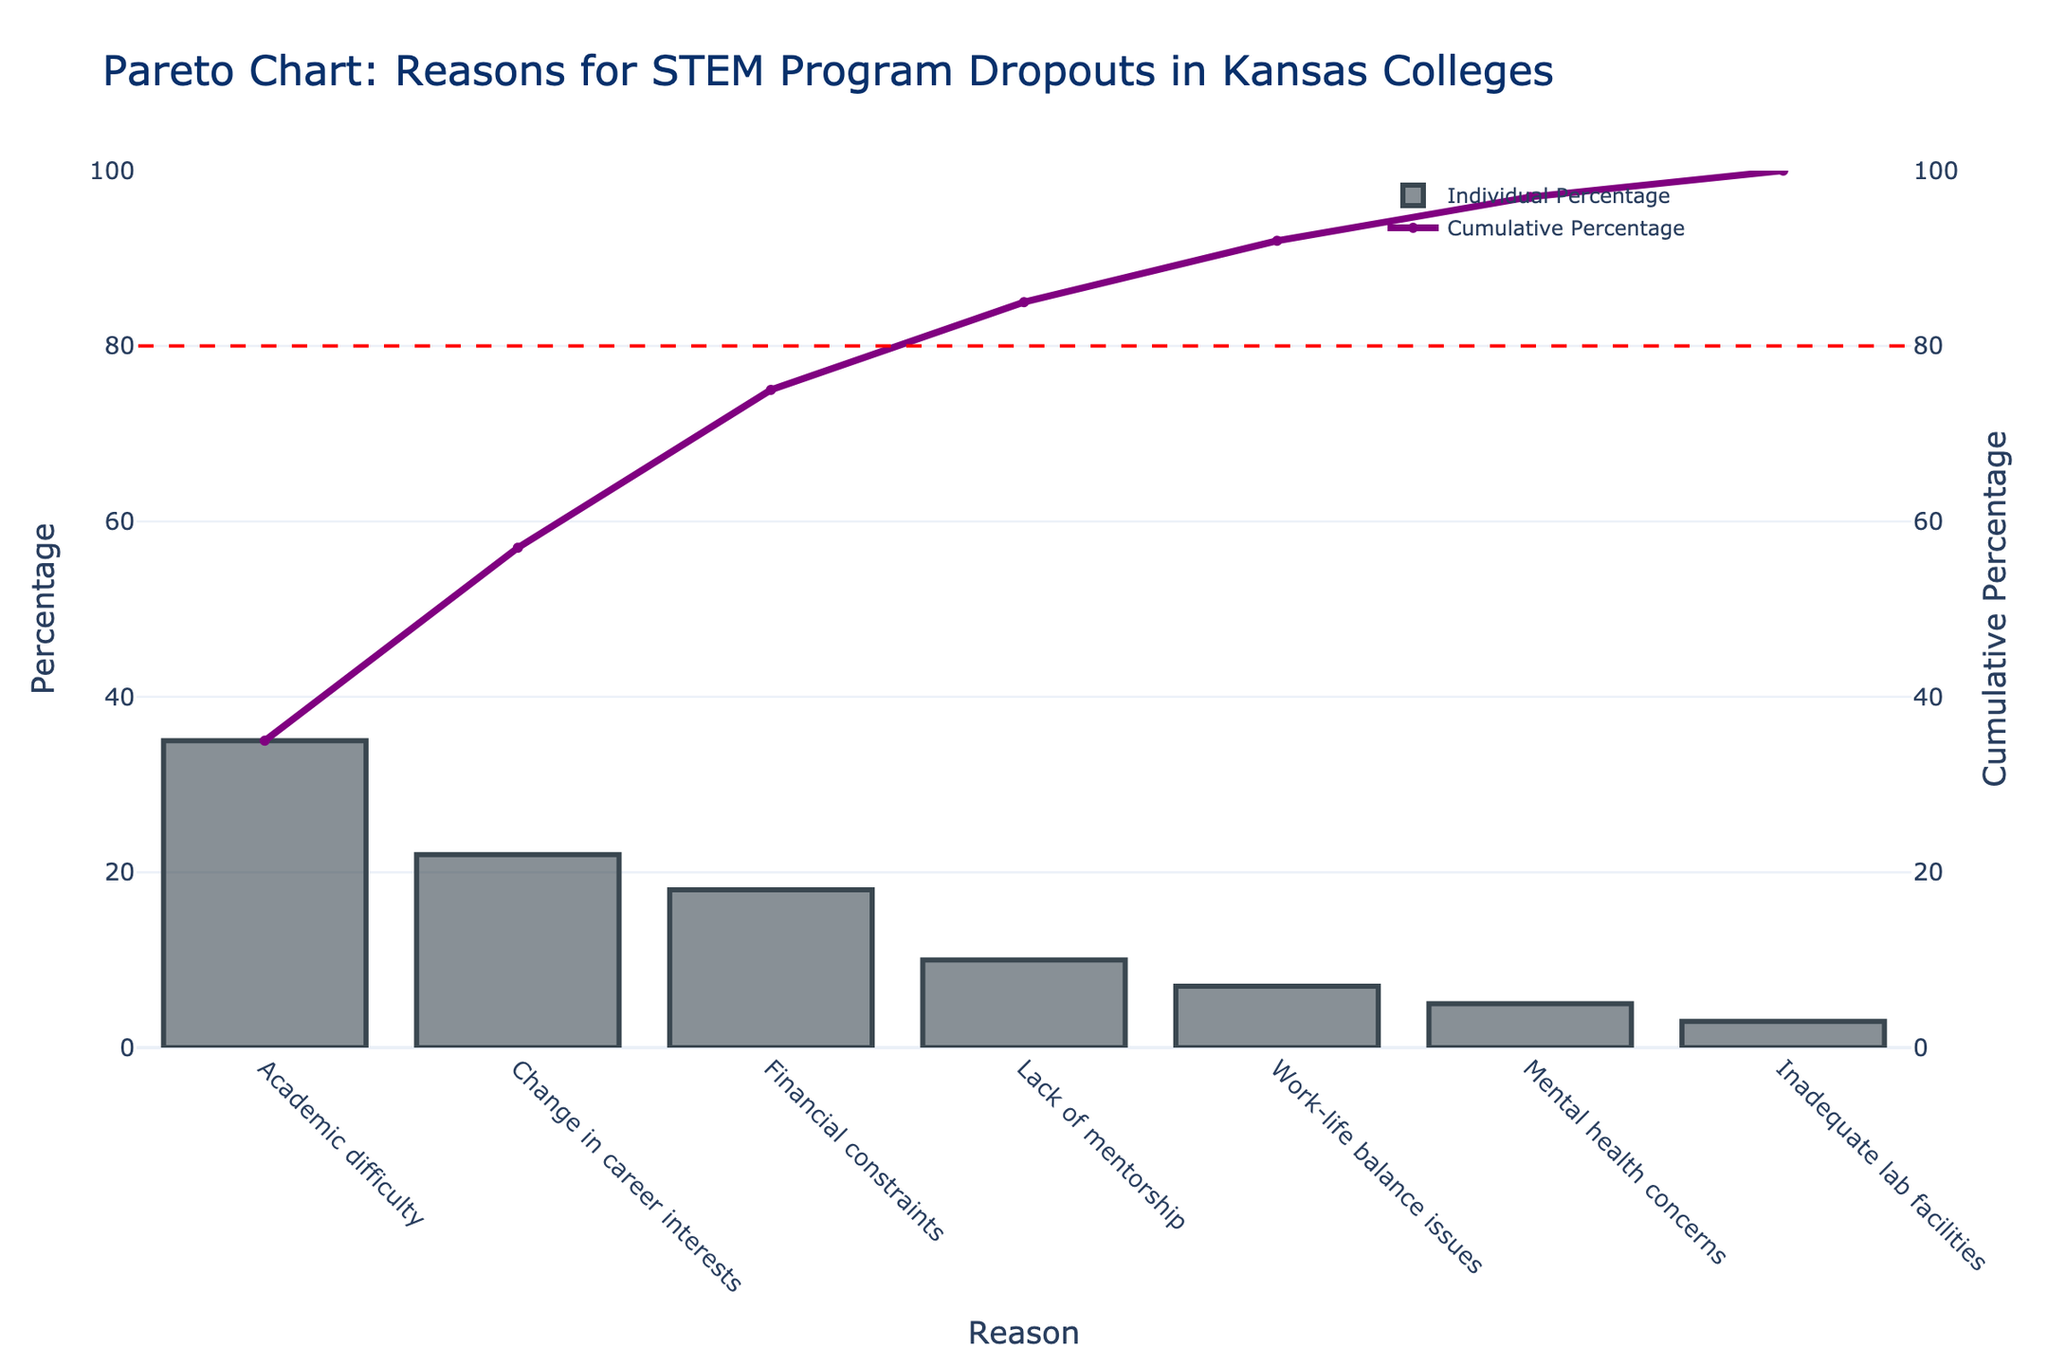What is the title of the chart? The title of the chart is located at the top and provides a summary of the chart's content. In this case, the title is found at the top center of the chart.
Answer: Pareto Chart: Reasons for STEM Program Dropouts in Kansas Colleges What reason accounts for the highest percentage of STEM program dropouts? The highest percentage bar represents the most frequent reason for dropouts and is positioned as the leftmost bar.
Answer: Academic difficulty What are the percentages for 'Work-life balance issues' and 'Inadequate lab facilities'? To find these percentages, locate the bars labeled 'Work-life balance issues' and 'Inadequate lab facilities' and read the height of each bar.
Answer: 7% and 3%, respectively Which reasons make up at least 80% of the cumulative percentage? The reasons contributing to at least 80% are those up to the point where the cumulative line meets the 80% reference line. These are found by following the cumulative percentage curve and marking the cumulative point closest to 80%.
Answer: Academic difficulty, Change in career interests, Financial constraints, Lack of mentorship What is the cumulative percentage after the first three reasons? Add the individual percentages of the first three reasons (35% for Academic difficulty, 22% for Change in career interests, 18% for Financial constraints) to find the cumulative percentage.
Answer: 75% Which reasons contribute less than 10% individually to the dropouts? Locate the bars whose heights are below 10% to identify these reasons.
Answer: Work-life balance issues, Mental health concerns, Inadequate lab facilities How do 'Academic difficulty' and 'Change in career interests' percentages compare? Compare the heights of the bars for these two reasons to see which is higher.
Answer: Academic difficulty is higher (35% vs. 22%) What is the difference in percentage between the highest and lowest reasons for dropout? Subtract the percentage of the lowest reason (3% for Inadequate lab facilities) from the percentage of the highest reason (35% for Academic difficulty).
Answer: 32% If the reason 'Mental health concerns' is excluded, what would be the new cumulative percentage after 'Work-life balance issues'? Exclude the percentage for 'Mental health concerns' (5%) and recalculate the cumulative percentage after 'Work-life balance issues' (35% + 22% + 18% + 10% + 7%).
Answer: 92% Which reason(s) falls exactly on the 80% cumulative percentage line? Identify the point at which the cumulative percentage line intersects the 80% reference line. This requires checking the cumulative percentage values for the consistency of the chart.
Answer: Lack of mentorship 